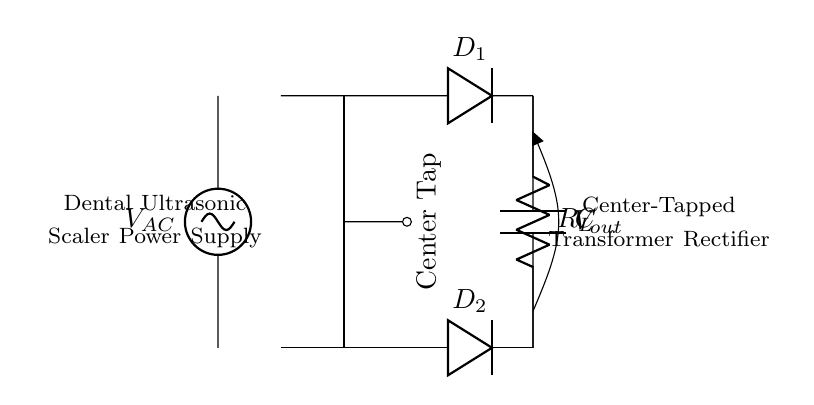What is the type of transformer used in this circuit? The transformer represented in the circuit is a center-tapped transformer. This can be identified by the marked center tap in the diagram and the symmetrical nature of the winding connections.
Answer: Center-tapped How many diodes are present in this circuit? The circuit diagram shows two diodes connected to the outputs of the transformer. Both diodes are labeled as D1 and D2.
Answer: Two What is the purpose of the capacitor in this circuit? The capacitor in the circuit is used for smoothing the rectified output voltage. It helps to reduce the ripple voltage in the output by storing charge and releasing it slowly, thereby stabilizing the voltage.
Answer: Smoothing What is the load resistor labeled in the circuit? The load resistor in the circuit is represented as R_L. It is connected across the load side of the rectifier, indicating that it is where the output voltage is applied.
Answer: R_L What kind of rectification does this circuit perform? The circuit performs full-wave rectification. This is because two diodes are used, allowing both halves of the AC waveform to be utilized to provide a continuous DC output, which is characteristic of full-wave rectification.
Answer: Full-wave What is the designation for the AC power supply input? The AC power supply input is marked as V_AC in the circuit. This designation indicates the alternating current voltage that powers the transformer and, subsequently, the rectifier circuit.
Answer: V_AC 